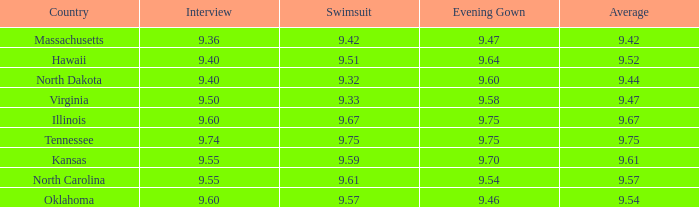Which country had the swimsuit score 9.67? Illinois. 